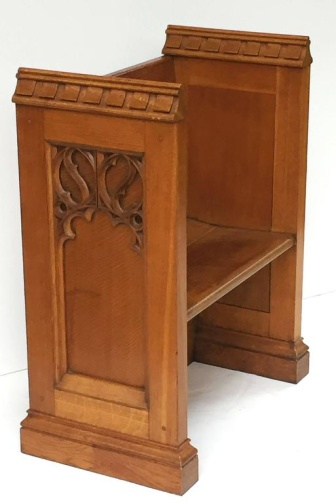Analyze the image in a comprehensive and detailed manner. The image showcases a solid wooden bench, showcasing both function and artistry. The bench, crafted from light-colored wood, is set against a plain white background, highlighting its structure. It is captured at a three-quarter angle, which allows for a detailed appreciation of its intricate design. The armrests and backrest are adorned with carved patterns, possibly hinting at a historical or cultural significance. Despite its old-fashioned design, the bench appears to be well-maintained, with no visible signs of damage or wear. Its robust build suggests it is not merely decorative but also serves a practical purpose. The absence of any text or additional objects in the image directs complete attention to the bench. The angle and positioning provide a sense of depth, making the bench the central focal point. Overall, the image effectively captures the blend of functionality and timeless beauty of this wooden bench. 